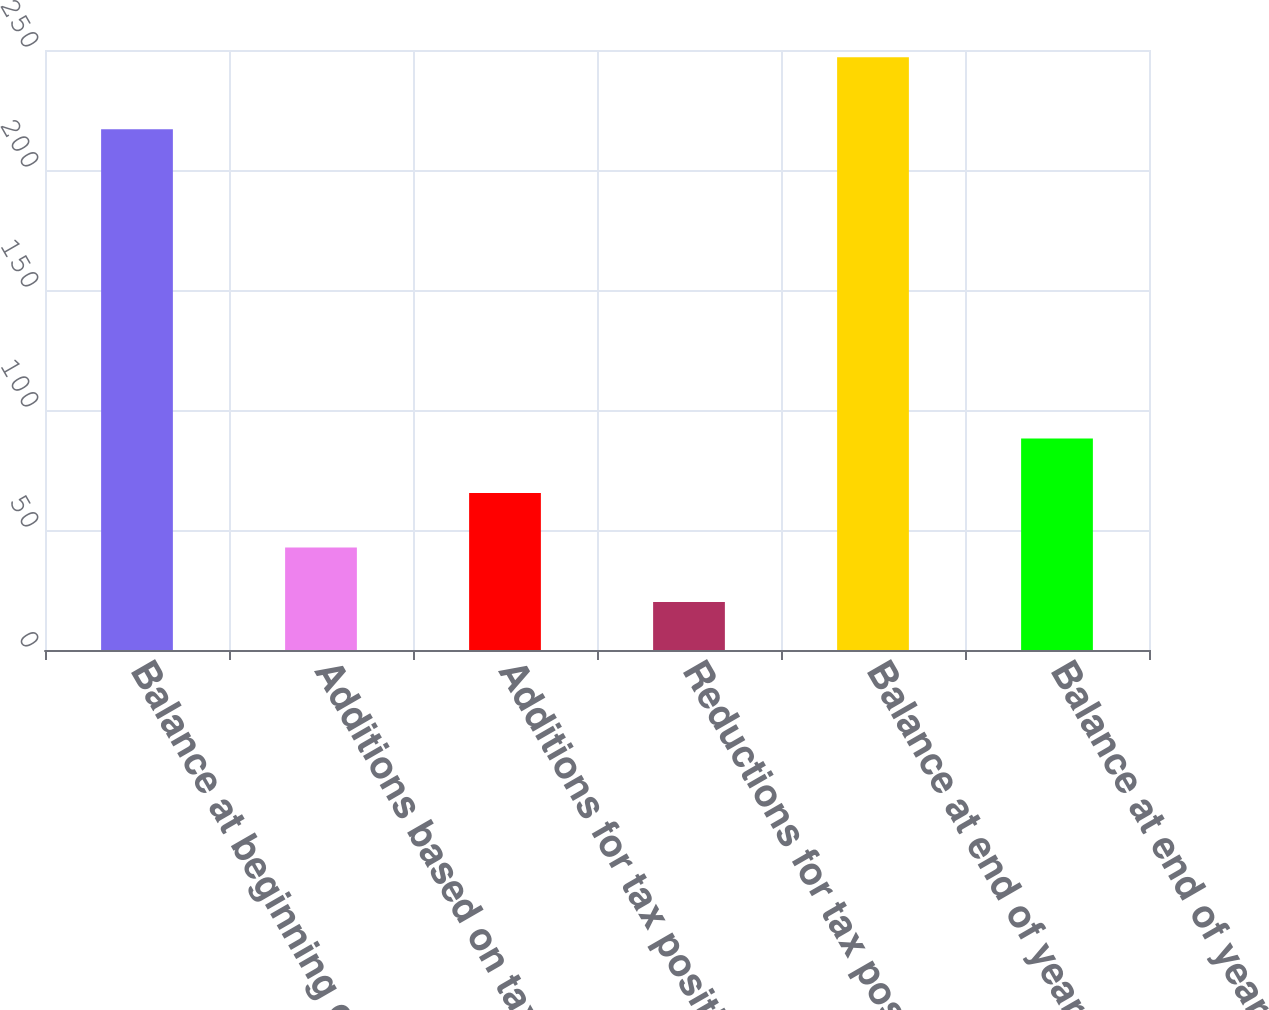<chart> <loc_0><loc_0><loc_500><loc_500><bar_chart><fcel>Balance at beginning of year<fcel>Additions based on tax<fcel>Additions for tax positions of<fcel>Reductions for tax positions<fcel>Balance at end of year<fcel>Balance at end of year net<nl><fcel>217<fcel>42.7<fcel>65.4<fcel>20<fcel>247<fcel>88.1<nl></chart> 